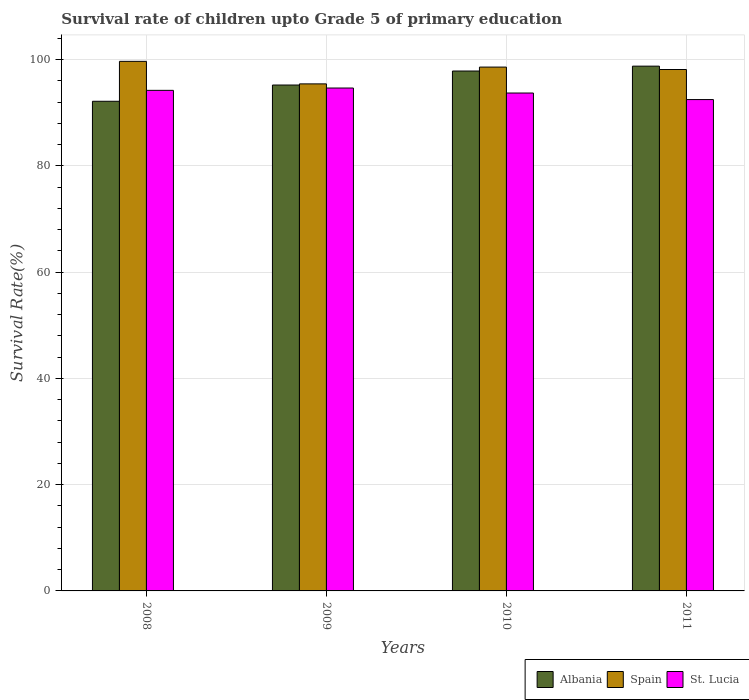How many different coloured bars are there?
Give a very brief answer. 3. How many groups of bars are there?
Your response must be concise. 4. Are the number of bars on each tick of the X-axis equal?
Ensure brevity in your answer.  Yes. How many bars are there on the 4th tick from the left?
Offer a terse response. 3. How many bars are there on the 2nd tick from the right?
Give a very brief answer. 3. What is the survival rate of children in Albania in 2010?
Provide a succinct answer. 97.86. Across all years, what is the maximum survival rate of children in St. Lucia?
Offer a terse response. 94.67. Across all years, what is the minimum survival rate of children in St. Lucia?
Make the answer very short. 92.49. In which year was the survival rate of children in Albania minimum?
Ensure brevity in your answer.  2008. What is the total survival rate of children in Albania in the graph?
Provide a short and direct response. 384.05. What is the difference between the survival rate of children in Albania in 2008 and that in 2009?
Ensure brevity in your answer.  -3.06. What is the difference between the survival rate of children in St. Lucia in 2011 and the survival rate of children in Spain in 2010?
Provide a succinct answer. -6.12. What is the average survival rate of children in Spain per year?
Your response must be concise. 97.97. In the year 2010, what is the difference between the survival rate of children in Spain and survival rate of children in St. Lucia?
Ensure brevity in your answer.  4.88. What is the ratio of the survival rate of children in St. Lucia in 2008 to that in 2011?
Provide a succinct answer. 1.02. Is the difference between the survival rate of children in Spain in 2008 and 2011 greater than the difference between the survival rate of children in St. Lucia in 2008 and 2011?
Provide a short and direct response. No. What is the difference between the highest and the second highest survival rate of children in St. Lucia?
Your response must be concise. 0.44. What is the difference between the highest and the lowest survival rate of children in St. Lucia?
Provide a succinct answer. 2.18. What does the 3rd bar from the left in 2008 represents?
Your answer should be compact. St. Lucia. Is it the case that in every year, the sum of the survival rate of children in Albania and survival rate of children in Spain is greater than the survival rate of children in St. Lucia?
Make the answer very short. Yes. How many bars are there?
Offer a very short reply. 12. Are all the bars in the graph horizontal?
Make the answer very short. No. How many years are there in the graph?
Your answer should be very brief. 4. What is the difference between two consecutive major ticks on the Y-axis?
Your response must be concise. 20. Does the graph contain grids?
Offer a terse response. Yes. Where does the legend appear in the graph?
Provide a short and direct response. Bottom right. How are the legend labels stacked?
Keep it short and to the point. Horizontal. What is the title of the graph?
Keep it short and to the point. Survival rate of children upto Grade 5 of primary education. What is the label or title of the Y-axis?
Make the answer very short. Survival Rate(%). What is the Survival Rate(%) in Albania in 2008?
Your answer should be compact. 92.17. What is the Survival Rate(%) in Spain in 2008?
Your answer should be very brief. 99.69. What is the Survival Rate(%) of St. Lucia in 2008?
Offer a terse response. 94.23. What is the Survival Rate(%) of Albania in 2009?
Offer a very short reply. 95.23. What is the Survival Rate(%) in Spain in 2009?
Your response must be concise. 95.44. What is the Survival Rate(%) in St. Lucia in 2009?
Give a very brief answer. 94.67. What is the Survival Rate(%) in Albania in 2010?
Offer a very short reply. 97.86. What is the Survival Rate(%) in Spain in 2010?
Keep it short and to the point. 98.61. What is the Survival Rate(%) in St. Lucia in 2010?
Your answer should be compact. 93.72. What is the Survival Rate(%) in Albania in 2011?
Your answer should be compact. 98.78. What is the Survival Rate(%) in Spain in 2011?
Offer a very short reply. 98.15. What is the Survival Rate(%) of St. Lucia in 2011?
Provide a succinct answer. 92.49. Across all years, what is the maximum Survival Rate(%) of Albania?
Your answer should be compact. 98.78. Across all years, what is the maximum Survival Rate(%) of Spain?
Ensure brevity in your answer.  99.69. Across all years, what is the maximum Survival Rate(%) of St. Lucia?
Ensure brevity in your answer.  94.67. Across all years, what is the minimum Survival Rate(%) of Albania?
Make the answer very short. 92.17. Across all years, what is the minimum Survival Rate(%) of Spain?
Keep it short and to the point. 95.44. Across all years, what is the minimum Survival Rate(%) of St. Lucia?
Offer a terse response. 92.49. What is the total Survival Rate(%) in Albania in the graph?
Give a very brief answer. 384.05. What is the total Survival Rate(%) of Spain in the graph?
Give a very brief answer. 391.89. What is the total Survival Rate(%) of St. Lucia in the graph?
Ensure brevity in your answer.  375.11. What is the difference between the Survival Rate(%) of Albania in 2008 and that in 2009?
Your answer should be compact. -3.06. What is the difference between the Survival Rate(%) of Spain in 2008 and that in 2009?
Your answer should be very brief. 4.24. What is the difference between the Survival Rate(%) of St. Lucia in 2008 and that in 2009?
Your response must be concise. -0.44. What is the difference between the Survival Rate(%) in Albania in 2008 and that in 2010?
Keep it short and to the point. -5.69. What is the difference between the Survival Rate(%) of Spain in 2008 and that in 2010?
Offer a very short reply. 1.08. What is the difference between the Survival Rate(%) in St. Lucia in 2008 and that in 2010?
Your response must be concise. 0.5. What is the difference between the Survival Rate(%) in Albania in 2008 and that in 2011?
Offer a very short reply. -6.61. What is the difference between the Survival Rate(%) in Spain in 2008 and that in 2011?
Offer a very short reply. 1.53. What is the difference between the Survival Rate(%) in St. Lucia in 2008 and that in 2011?
Make the answer very short. 1.74. What is the difference between the Survival Rate(%) in Albania in 2009 and that in 2010?
Your answer should be very brief. -2.64. What is the difference between the Survival Rate(%) in Spain in 2009 and that in 2010?
Ensure brevity in your answer.  -3.16. What is the difference between the Survival Rate(%) of St. Lucia in 2009 and that in 2010?
Your answer should be compact. 0.94. What is the difference between the Survival Rate(%) in Albania in 2009 and that in 2011?
Make the answer very short. -3.55. What is the difference between the Survival Rate(%) of Spain in 2009 and that in 2011?
Provide a short and direct response. -2.71. What is the difference between the Survival Rate(%) of St. Lucia in 2009 and that in 2011?
Offer a terse response. 2.18. What is the difference between the Survival Rate(%) in Albania in 2010 and that in 2011?
Provide a succinct answer. -0.92. What is the difference between the Survival Rate(%) of Spain in 2010 and that in 2011?
Offer a very short reply. 0.45. What is the difference between the Survival Rate(%) in St. Lucia in 2010 and that in 2011?
Ensure brevity in your answer.  1.23. What is the difference between the Survival Rate(%) of Albania in 2008 and the Survival Rate(%) of Spain in 2009?
Give a very brief answer. -3.27. What is the difference between the Survival Rate(%) in Albania in 2008 and the Survival Rate(%) in St. Lucia in 2009?
Provide a succinct answer. -2.5. What is the difference between the Survival Rate(%) in Spain in 2008 and the Survival Rate(%) in St. Lucia in 2009?
Your response must be concise. 5.02. What is the difference between the Survival Rate(%) in Albania in 2008 and the Survival Rate(%) in Spain in 2010?
Give a very brief answer. -6.44. What is the difference between the Survival Rate(%) in Albania in 2008 and the Survival Rate(%) in St. Lucia in 2010?
Offer a terse response. -1.55. What is the difference between the Survival Rate(%) in Spain in 2008 and the Survival Rate(%) in St. Lucia in 2010?
Your answer should be compact. 5.96. What is the difference between the Survival Rate(%) of Albania in 2008 and the Survival Rate(%) of Spain in 2011?
Offer a very short reply. -5.98. What is the difference between the Survival Rate(%) in Albania in 2008 and the Survival Rate(%) in St. Lucia in 2011?
Provide a short and direct response. -0.32. What is the difference between the Survival Rate(%) in Spain in 2008 and the Survival Rate(%) in St. Lucia in 2011?
Provide a short and direct response. 7.2. What is the difference between the Survival Rate(%) of Albania in 2009 and the Survival Rate(%) of Spain in 2010?
Ensure brevity in your answer.  -3.38. What is the difference between the Survival Rate(%) in Albania in 2009 and the Survival Rate(%) in St. Lucia in 2010?
Give a very brief answer. 1.5. What is the difference between the Survival Rate(%) in Spain in 2009 and the Survival Rate(%) in St. Lucia in 2010?
Give a very brief answer. 1.72. What is the difference between the Survival Rate(%) of Albania in 2009 and the Survival Rate(%) of Spain in 2011?
Ensure brevity in your answer.  -2.92. What is the difference between the Survival Rate(%) of Albania in 2009 and the Survival Rate(%) of St. Lucia in 2011?
Ensure brevity in your answer.  2.74. What is the difference between the Survival Rate(%) in Spain in 2009 and the Survival Rate(%) in St. Lucia in 2011?
Make the answer very short. 2.95. What is the difference between the Survival Rate(%) in Albania in 2010 and the Survival Rate(%) in Spain in 2011?
Your answer should be compact. -0.29. What is the difference between the Survival Rate(%) of Albania in 2010 and the Survival Rate(%) of St. Lucia in 2011?
Provide a short and direct response. 5.37. What is the difference between the Survival Rate(%) in Spain in 2010 and the Survival Rate(%) in St. Lucia in 2011?
Give a very brief answer. 6.12. What is the average Survival Rate(%) in Albania per year?
Your answer should be compact. 96.01. What is the average Survival Rate(%) in Spain per year?
Offer a very short reply. 97.97. What is the average Survival Rate(%) of St. Lucia per year?
Your response must be concise. 93.78. In the year 2008, what is the difference between the Survival Rate(%) of Albania and Survival Rate(%) of Spain?
Your answer should be compact. -7.52. In the year 2008, what is the difference between the Survival Rate(%) of Albania and Survival Rate(%) of St. Lucia?
Your answer should be compact. -2.06. In the year 2008, what is the difference between the Survival Rate(%) of Spain and Survival Rate(%) of St. Lucia?
Provide a short and direct response. 5.46. In the year 2009, what is the difference between the Survival Rate(%) in Albania and Survival Rate(%) in Spain?
Your response must be concise. -0.21. In the year 2009, what is the difference between the Survival Rate(%) of Albania and Survival Rate(%) of St. Lucia?
Offer a terse response. 0.56. In the year 2009, what is the difference between the Survival Rate(%) of Spain and Survival Rate(%) of St. Lucia?
Keep it short and to the point. 0.78. In the year 2010, what is the difference between the Survival Rate(%) of Albania and Survival Rate(%) of Spain?
Provide a succinct answer. -0.74. In the year 2010, what is the difference between the Survival Rate(%) of Albania and Survival Rate(%) of St. Lucia?
Offer a terse response. 4.14. In the year 2010, what is the difference between the Survival Rate(%) of Spain and Survival Rate(%) of St. Lucia?
Ensure brevity in your answer.  4.88. In the year 2011, what is the difference between the Survival Rate(%) of Albania and Survival Rate(%) of Spain?
Keep it short and to the point. 0.63. In the year 2011, what is the difference between the Survival Rate(%) of Albania and Survival Rate(%) of St. Lucia?
Your response must be concise. 6.29. In the year 2011, what is the difference between the Survival Rate(%) in Spain and Survival Rate(%) in St. Lucia?
Offer a terse response. 5.66. What is the ratio of the Survival Rate(%) of Albania in 2008 to that in 2009?
Provide a succinct answer. 0.97. What is the ratio of the Survival Rate(%) of Spain in 2008 to that in 2009?
Offer a terse response. 1.04. What is the ratio of the Survival Rate(%) of St. Lucia in 2008 to that in 2009?
Make the answer very short. 1. What is the ratio of the Survival Rate(%) in Albania in 2008 to that in 2010?
Your response must be concise. 0.94. What is the ratio of the Survival Rate(%) of Spain in 2008 to that in 2010?
Offer a very short reply. 1.01. What is the ratio of the Survival Rate(%) in St. Lucia in 2008 to that in 2010?
Provide a short and direct response. 1.01. What is the ratio of the Survival Rate(%) in Albania in 2008 to that in 2011?
Ensure brevity in your answer.  0.93. What is the ratio of the Survival Rate(%) of Spain in 2008 to that in 2011?
Ensure brevity in your answer.  1.02. What is the ratio of the Survival Rate(%) of St. Lucia in 2008 to that in 2011?
Ensure brevity in your answer.  1.02. What is the ratio of the Survival Rate(%) of Albania in 2009 to that in 2010?
Offer a very short reply. 0.97. What is the ratio of the Survival Rate(%) in Spain in 2009 to that in 2010?
Make the answer very short. 0.97. What is the ratio of the Survival Rate(%) in St. Lucia in 2009 to that in 2010?
Keep it short and to the point. 1.01. What is the ratio of the Survival Rate(%) in Spain in 2009 to that in 2011?
Keep it short and to the point. 0.97. What is the ratio of the Survival Rate(%) of St. Lucia in 2009 to that in 2011?
Your response must be concise. 1.02. What is the ratio of the Survival Rate(%) of Spain in 2010 to that in 2011?
Ensure brevity in your answer.  1. What is the ratio of the Survival Rate(%) of St. Lucia in 2010 to that in 2011?
Your answer should be very brief. 1.01. What is the difference between the highest and the second highest Survival Rate(%) of Albania?
Your answer should be very brief. 0.92. What is the difference between the highest and the second highest Survival Rate(%) in Spain?
Your answer should be compact. 1.08. What is the difference between the highest and the second highest Survival Rate(%) in St. Lucia?
Provide a short and direct response. 0.44. What is the difference between the highest and the lowest Survival Rate(%) of Albania?
Make the answer very short. 6.61. What is the difference between the highest and the lowest Survival Rate(%) of Spain?
Keep it short and to the point. 4.24. What is the difference between the highest and the lowest Survival Rate(%) of St. Lucia?
Give a very brief answer. 2.18. 